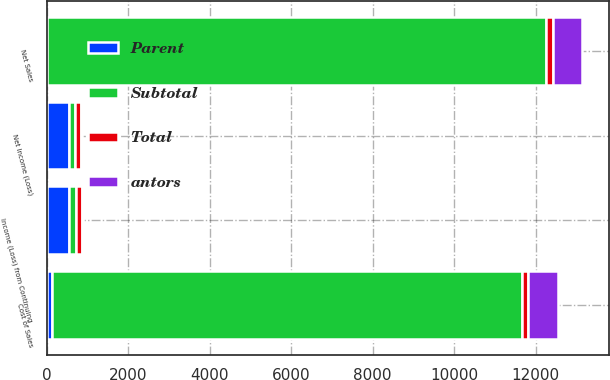<chart> <loc_0><loc_0><loc_500><loc_500><stacked_bar_chart><ecel><fcel>Net Sales<fcel>Cost of Sales<fcel>Income (Loss) from Continuing<fcel>Net Income (Loss)<nl><fcel>Parent<fcel>11<fcel>132<fcel>558<fcel>537<nl><fcel>Subtotal<fcel>12245<fcel>11526<fcel>160<fcel>160<nl><fcel>antors<fcel>725<fcel>725<fcel>13<fcel>13<nl><fcel>Total<fcel>160<fcel>160<fcel>155<fcel>150<nl></chart> 